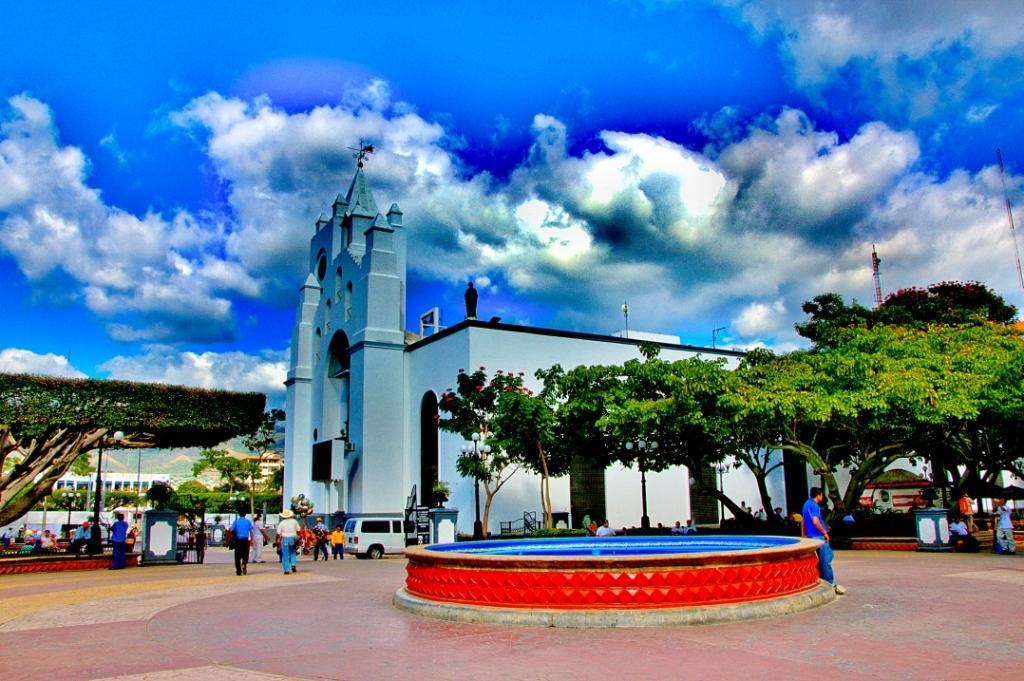In one or two sentences, can you explain what this image depicts? In this image we can see an animated picture. In the picture we can see sky with clouds, buildings, trees, poles, motor vehicles on the ground and people standing on the floor. 